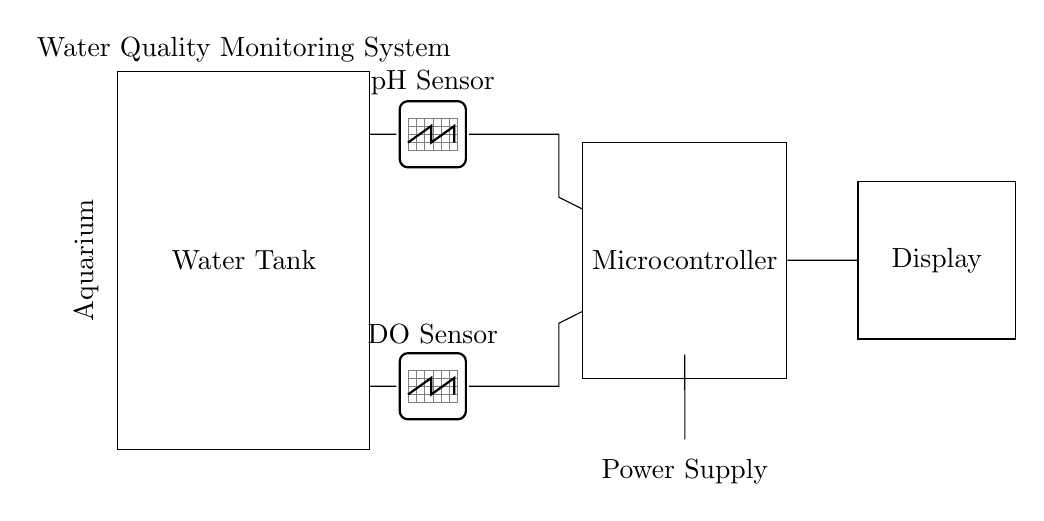What types of sensors are included in the circuit? The circuit diagram shows two types of sensors: a pH Sensor and a Dissolved Oxygen (DO) Sensor. These are explicitly labeled in the diagram.
Answer: pH Sensor, Dissolved Oxygen Sensor What is the primary function of the microcontroller in this circuit? The microcontroller is responsible for processing the signals from the sensors and controlling the display output. Its central position indicates it serves as the control unit for the data collected from the sensors.
Answer: Data processing Which component is responsible for power supply? The power supply is represented by a battery symbol located at the bottom right, indicating that it is the source of energy for the circuit.
Answer: Battery How does the pH sensor connect to the microcontroller? The pH sensor connects to the microcontroller through a direct line from the sensor to the microcontroller via a terminal at (7,5). This indicates a signal path for data transmission.
Answer: Direct line What can be inferred about the type of display used in the system? The display is labeled generically as "Display" in the circuit; however, it can be inferred that it is likely an LCD or LED based on its typical application for showing real-time measurements from sensors.
Answer: Display What might happen if the dissolved oxygen sensor fails in the system? If the dissolved oxygen sensor fails, the microcontroller would receive no data from that sensor, potentially affecting the overall water quality assessment in the aquarium. It may lead to a failure in monitoring dissolved oxygen levels.
Answer: Monitoring failure How many components are connected to the microcontroller? The microcontroller is connected to two components: the pH sensor and the dissolved oxygen sensor, which indicates that it integrates data from both sensors.
Answer: Two components 